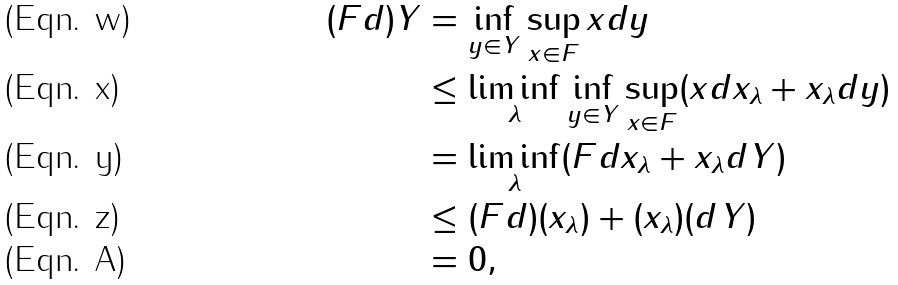Convert formula to latex. <formula><loc_0><loc_0><loc_500><loc_500>( F d ) Y & = \inf _ { y \in Y } \sup _ { x \in F } x d y \\ & \leq \liminf _ { \lambda } \inf _ { y \in Y } \sup _ { x \in F } ( x d x _ { \lambda } + x _ { \lambda } d y ) \\ & = \liminf _ { \lambda } ( F d x _ { \lambda } + x _ { \lambda } d Y ) \\ & \leq ( F d ) ( x _ { \lambda } ) + ( x _ { \lambda } ) ( d Y ) \\ & = 0 ,</formula> 